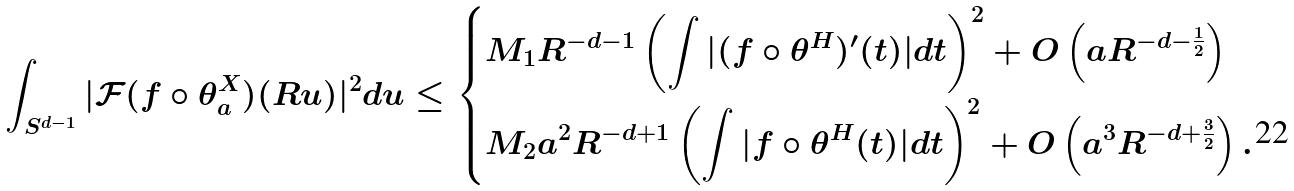<formula> <loc_0><loc_0><loc_500><loc_500>\int _ { S ^ { d - 1 } } | \mathcal { F } ( f \circ \theta _ { a } ^ { X } ) ( R u ) | ^ { 2 } d u \leq \begin{dcases} M _ { 1 } R ^ { - d - 1 } \left ( \int | ( f \circ \theta ^ { H } ) ^ { \prime } ( t ) | d t \right ) ^ { 2 } + O \left ( a R ^ { - d - \frac { 1 } { 2 } } \right ) \\ M _ { 2 } a ^ { 2 } R ^ { - d + 1 } \left ( \int | f \circ \theta ^ { H } ( t ) | d t \right ) ^ { 2 } + O \left ( a ^ { 3 } R ^ { - d + \frac { 3 } { 2 } } \right ) . \end{dcases}</formula> 